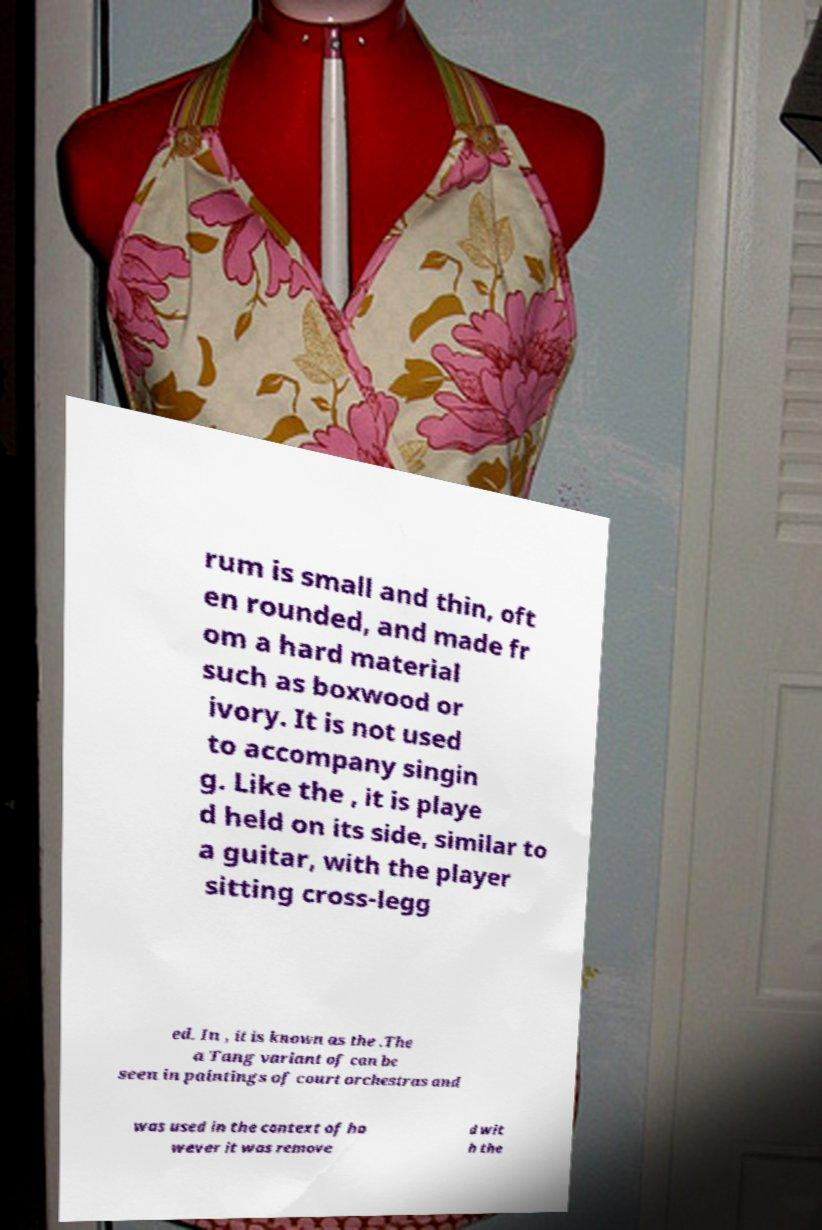Can you read and provide the text displayed in the image?This photo seems to have some interesting text. Can you extract and type it out for me? rum is small and thin, oft en rounded, and made fr om a hard material such as boxwood or ivory. It is not used to accompany singin g. Like the , it is playe d held on its side, similar to a guitar, with the player sitting cross-legg ed. In , it is known as the .The a Tang variant of can be seen in paintings of court orchestras and was used in the context of ho wever it was remove d wit h the 